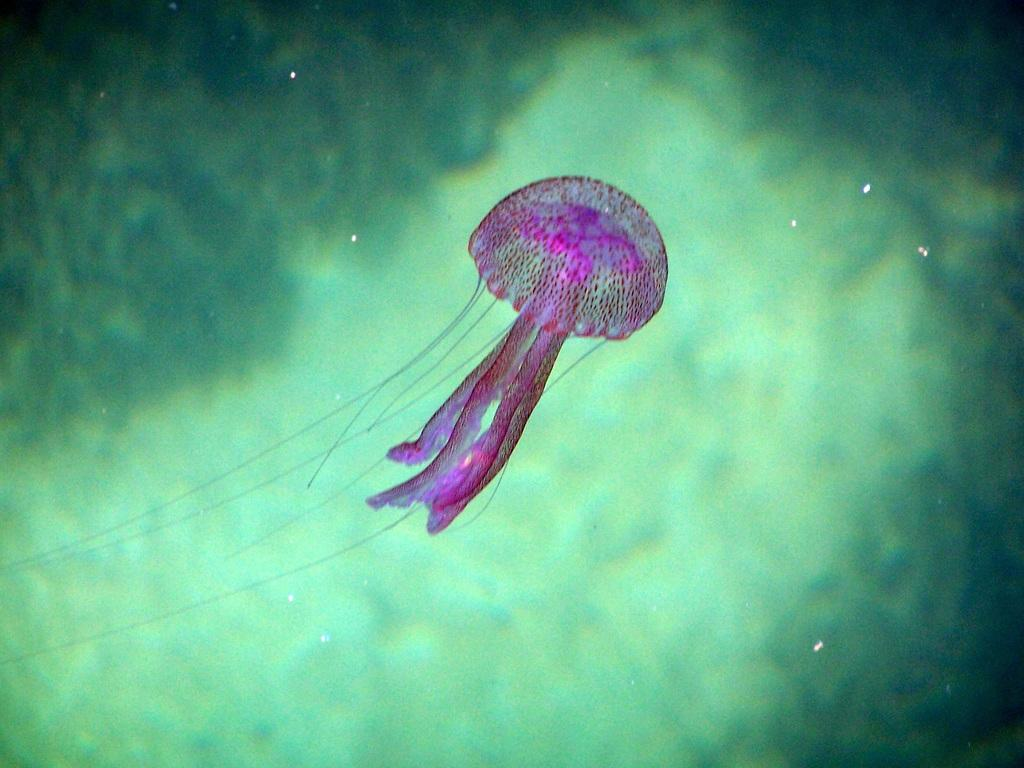What type of animal is in the water in the image? There is a jellyfish in the water in the image. Where is the water located? The water is in an ocean. What color is the background of the image? The background is green in color. What type of garden can be seen in the background of the image? There is no garden present in the image; the background is green in color, but it does not depict a garden. 